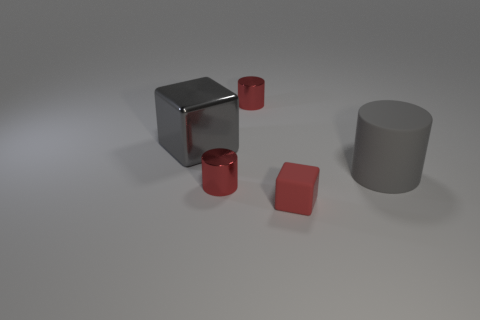What number of brown things are either rubber cylinders or matte cubes?
Ensure brevity in your answer.  0. What is the material of the red thing that is the same shape as the gray metal object?
Ensure brevity in your answer.  Rubber. There is a big gray thing on the right side of the tiny red matte block; what shape is it?
Make the answer very short. Cylinder. Is there a big yellow ball that has the same material as the gray cube?
Ensure brevity in your answer.  No. Do the metallic block and the rubber cylinder have the same size?
Offer a terse response. Yes. How many blocks are either big gray shiny objects or tiny red matte objects?
Offer a very short reply. 2. There is a big thing that is the same color as the large rubber cylinder; what is it made of?
Your response must be concise. Metal. How many other large objects are the same shape as the large gray metallic object?
Give a very brief answer. 0. Is the number of gray blocks to the left of the big gray metal object greater than the number of tiny red metal cylinders in front of the matte cylinder?
Ensure brevity in your answer.  No. There is a rubber thing that is right of the red rubber thing; is it the same color as the small rubber object?
Make the answer very short. No. 